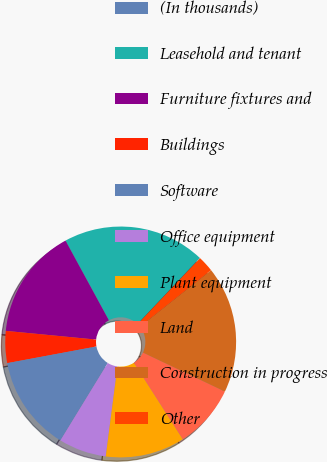Convert chart. <chart><loc_0><loc_0><loc_500><loc_500><pie_chart><fcel>(In thousands)<fcel>Leasehold and tenant<fcel>Furniture fixtures and<fcel>Buildings<fcel>Software<fcel>Office equipment<fcel>Plant equipment<fcel>Land<fcel>Construction in progress<fcel>Other<nl><fcel>0.04%<fcel>19.96%<fcel>15.53%<fcel>4.47%<fcel>13.32%<fcel>6.68%<fcel>11.11%<fcel>8.89%<fcel>17.75%<fcel>2.25%<nl></chart> 